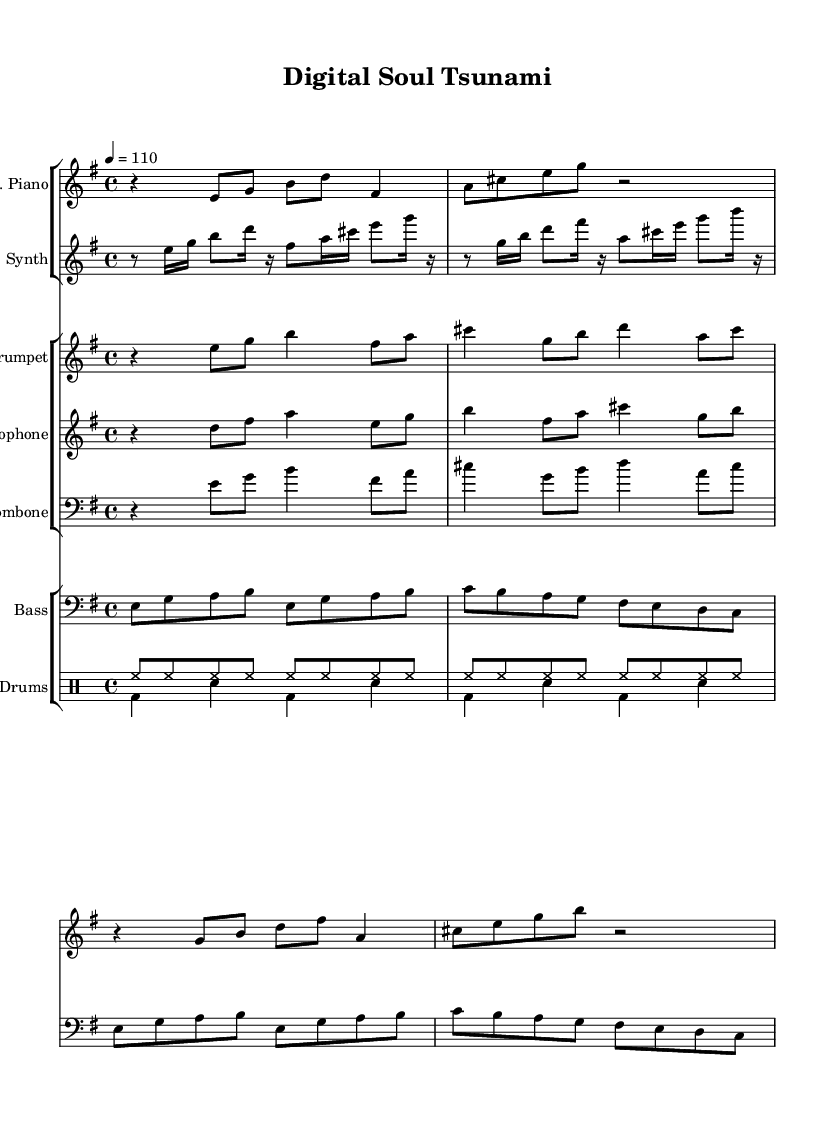What is the key signature of this music? The key signature is indicated by the key signature symbol at the beginning of the music. The notation shows 1 sharp which corresponds to E minor.
Answer: E minor What is the time signature of this music? The time signature appears prominently at the beginning of the score in the conventional format, showing there are four beats per measure with a quarter note getting one beat.
Answer: 4/4 What is the tempo marking for this piece? The tempo marking is represented by a numerical indication at the beginning of the music, specifying the beats per minute. In this case, it is set to 110 beats per minute.
Answer: 110 Which instruments are featured in this score? The score lists the distinct instruments by their names in the staff sections; these include Electric Piano, Synth, Trumpet, Saxophone, Trombone, Bass, and Drums.
Answer: Electric Piano, Synth, Trumpet, Saxophone, Trombone, Bass, Drums How many measures does the Electric Piano part contain? By counting the grouped segments divided by bar lines in the Electric Piano part, we observe there are eight measures present in the piece.
Answer: Eight What is the primary musical rhythm used for the drums? The drum patterns show distinct rhythmic patterns for each part. The high hat plays consistent eighth notes while the bass drum and snare alternate with four measures of a basic groove.
Answer: Eighth notes Which two instrumental sections contain a repeated melodic motif? Reviewing the structure of the piece reveals that both the Electric Piano and the Synth sections repeat similar melodic phrases, creating a cohesive sound.
Answer: Electric Piano, Synth 